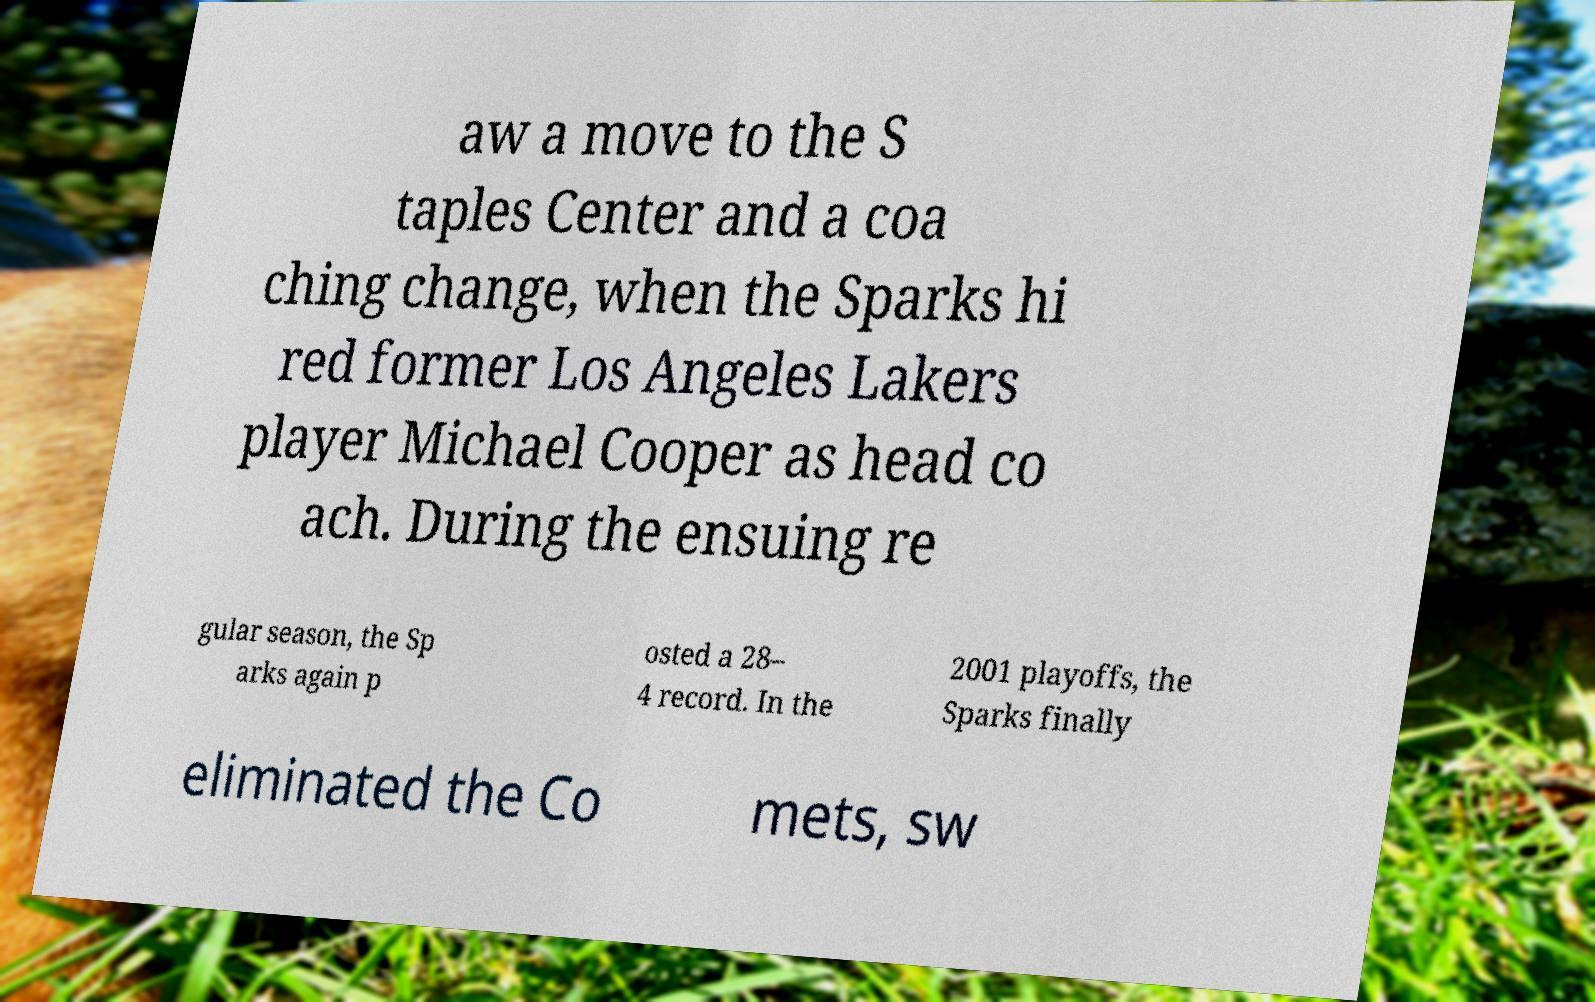Please identify and transcribe the text found in this image. aw a move to the S taples Center and a coa ching change, when the Sparks hi red former Los Angeles Lakers player Michael Cooper as head co ach. During the ensuing re gular season, the Sp arks again p osted a 28– 4 record. In the 2001 playoffs, the Sparks finally eliminated the Co mets, sw 